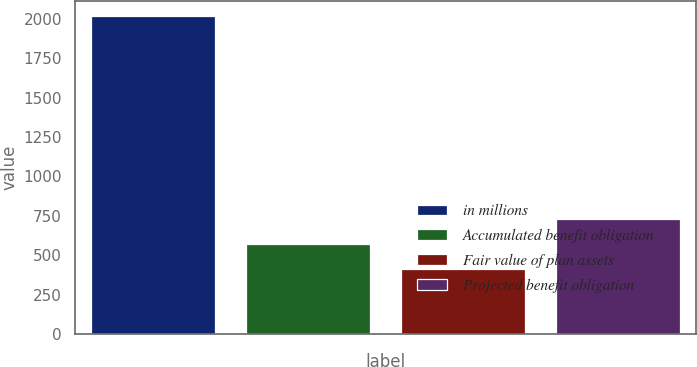Convert chart. <chart><loc_0><loc_0><loc_500><loc_500><bar_chart><fcel>in millions<fcel>Accumulated benefit obligation<fcel>Fair value of plan assets<fcel>Projected benefit obligation<nl><fcel>2016<fcel>572.04<fcel>411.6<fcel>732.48<nl></chart> 